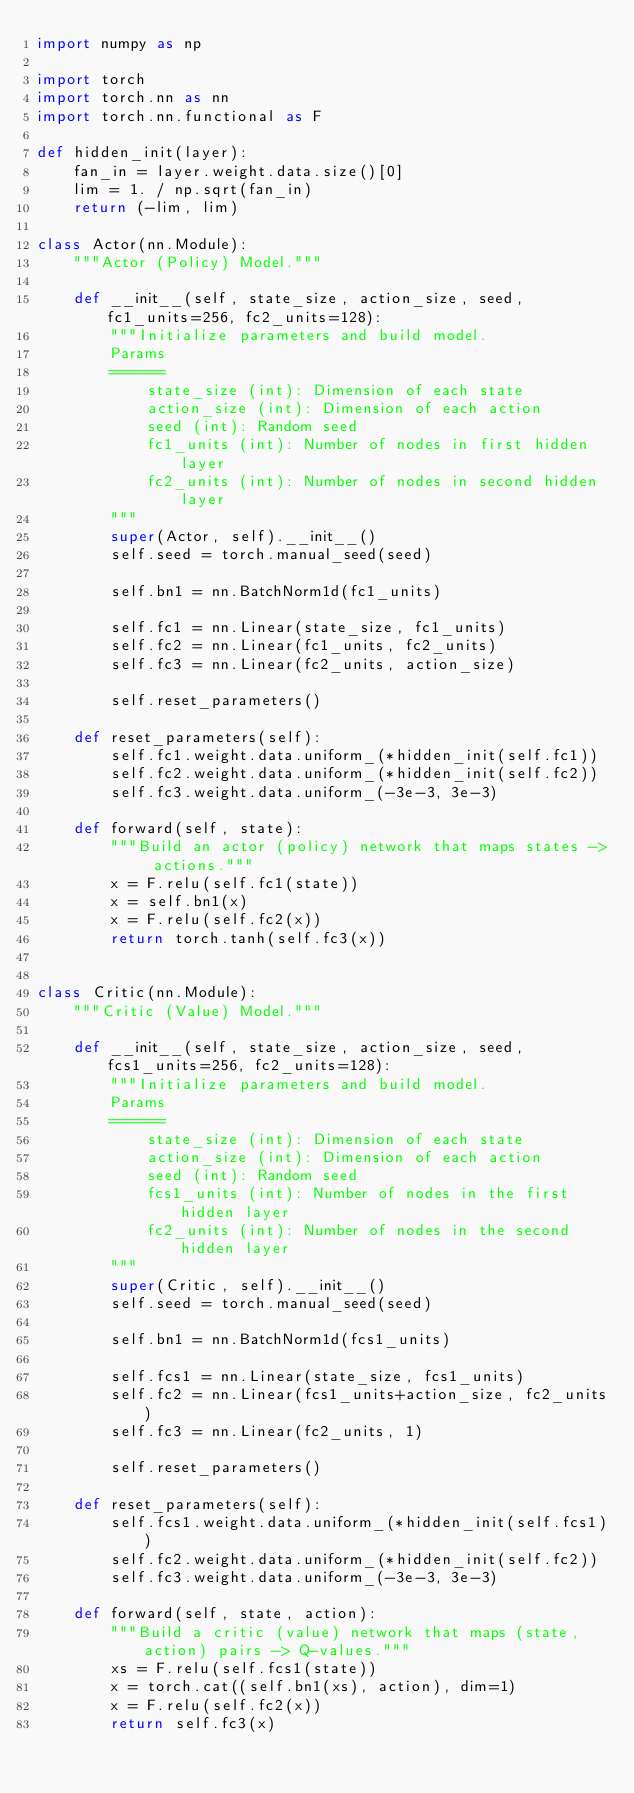<code> <loc_0><loc_0><loc_500><loc_500><_Python_>import numpy as np

import torch
import torch.nn as nn
import torch.nn.functional as F

def hidden_init(layer):
    fan_in = layer.weight.data.size()[0]
    lim = 1. / np.sqrt(fan_in)
    return (-lim, lim)

class Actor(nn.Module):
    """Actor (Policy) Model."""

    def __init__(self, state_size, action_size, seed, fc1_units=256, fc2_units=128):
        """Initialize parameters and build model.
        Params
        ======
            state_size (int): Dimension of each state
            action_size (int): Dimension of each action
            seed (int): Random seed
            fc1_units (int): Number of nodes in first hidden layer
            fc2_units (int): Number of nodes in second hidden layer
        """
        super(Actor, self).__init__()
        self.seed = torch.manual_seed(seed)
        
        self.bn1 = nn.BatchNorm1d(fc1_units)
        
        self.fc1 = nn.Linear(state_size, fc1_units)
        self.fc2 = nn.Linear(fc1_units, fc2_units)
        self.fc3 = nn.Linear(fc2_units, action_size)
        
        self.reset_parameters()

    def reset_parameters(self):
        self.fc1.weight.data.uniform_(*hidden_init(self.fc1))
        self.fc2.weight.data.uniform_(*hidden_init(self.fc2))
        self.fc3.weight.data.uniform_(-3e-3, 3e-3)

    def forward(self, state):
        """Build an actor (policy) network that maps states -> actions."""
        x = F.relu(self.fc1(state))
        x = self.bn1(x)
        x = F.relu(self.fc2(x))
        return torch.tanh(self.fc3(x))


class Critic(nn.Module):
    """Critic (Value) Model."""

    def __init__(self, state_size, action_size, seed, fcs1_units=256, fc2_units=128):
        """Initialize parameters and build model.
        Params
        ======
            state_size (int): Dimension of each state
            action_size (int): Dimension of each action
            seed (int): Random seed
            fcs1_units (int): Number of nodes in the first hidden layer
            fc2_units (int): Number of nodes in the second hidden layer
        """
        super(Critic, self).__init__()
        self.seed = torch.manual_seed(seed)
        
        self.bn1 = nn.BatchNorm1d(fcs1_units)
        
        self.fcs1 = nn.Linear(state_size, fcs1_units)
        self.fc2 = nn.Linear(fcs1_units+action_size, fc2_units)
        self.fc3 = nn.Linear(fc2_units, 1)
        
        self.reset_parameters()

    def reset_parameters(self):
        self.fcs1.weight.data.uniform_(*hidden_init(self.fcs1))
        self.fc2.weight.data.uniform_(*hidden_init(self.fc2))
        self.fc3.weight.data.uniform_(-3e-3, 3e-3)

    def forward(self, state, action):
        """Build a critic (value) network that maps (state, action) pairs -> Q-values."""
        xs = F.relu(self.fcs1(state))
        x = torch.cat((self.bn1(xs), action), dim=1)
        x = F.relu(self.fc2(x))
        return self.fc3(x)
</code> 